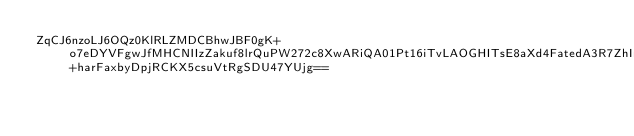<code> <loc_0><loc_0><loc_500><loc_500><_SML_>ZqCJ6nzoLJ6OQz0KlRLZMDCBhwJBF0gK+o7eDYVFgwJfMHCNIIzZakuf8lrQuPW272c8XwARiQA01Pt16iTvLAOGHITsE8aXd4FatedA3R7ZhIrVihwCQgGUJYP0iYEtF3vwoddgt1xVfYGcmOToRmp8rYc53C1PMm9LvIKIYnlRM+harFaxbyDpjRCKX5csuVtRgSDU47YUjg==</code> 